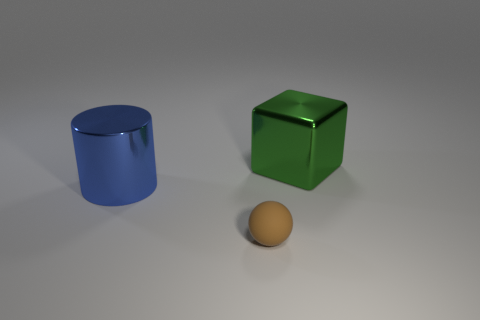Are there any other things that are the same material as the tiny object?
Offer a very short reply. No. What is the shape of the object that is in front of the metal thing that is left of the large object that is right of the big metal cylinder?
Your answer should be very brief. Sphere. Does the shiny thing that is to the right of the blue thing have the same size as the thing that is in front of the big cylinder?
Provide a short and direct response. No. What number of blue cylinders have the same material as the tiny brown ball?
Offer a very short reply. 0. What number of large shiny things are behind the big shiny object that is in front of the metal object behind the big blue metal thing?
Offer a terse response. 1. The green thing that is the same size as the blue metallic object is what shape?
Give a very brief answer. Cube. There is a big thing behind the big thing that is left of the shiny thing that is on the right side of the big blue shiny thing; what is its material?
Give a very brief answer. Metal. Is the size of the green shiny block the same as the sphere?
Give a very brief answer. No. What material is the blue cylinder?
Keep it short and to the point. Metal. What number of things are small brown rubber balls or tiny purple metal objects?
Give a very brief answer. 1. 